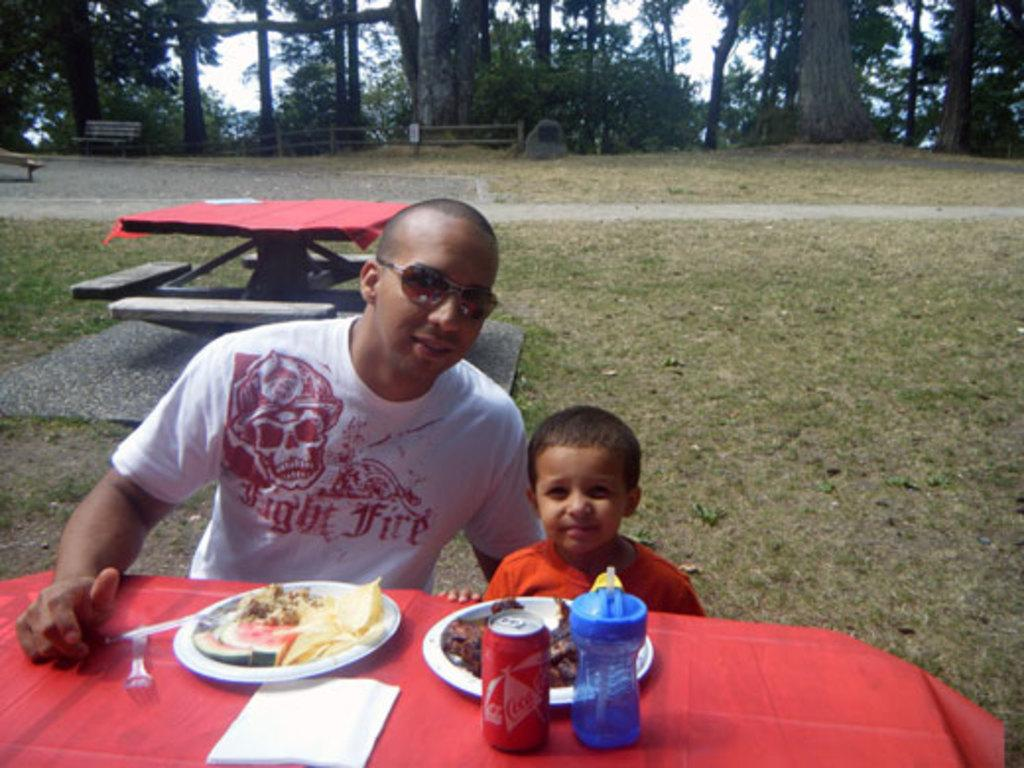Who are the people in the image? There is a man and a boy in the image. What are the man and the boy doing in the image? The man and the boy are sitting in front of a table. What can be seen on the table in the image? There is a fourth served on the table. What type of jam is being spread on the toothbrush in the image? There is no jam or toothbrush present in the image. 